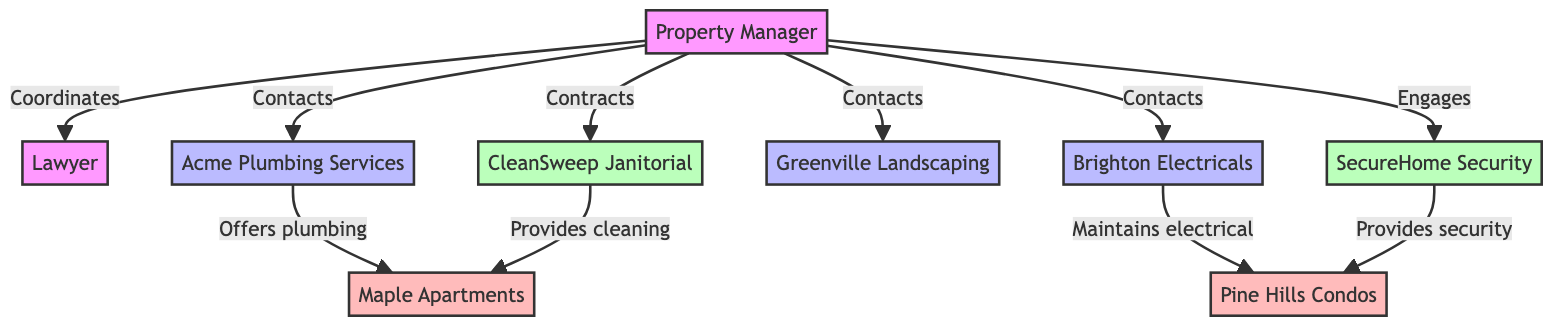What is the role of the Lawyer in the diagram? The diagram indicates that the Lawyer drafts and reviews rental and service agreements, which is highlighted in the relationship between the Property Manager and the Lawyer.
Answer: Drafts and reviews agreements How many contractors are shown in the diagram? By counting the entities listed under Contractors, we identify three contractors: Acme Plumbing Services, Brighton Electricals, and Greenville Landscaping.
Answer: Three Which property does SecureHome Security provide services for? The relationship between SecureHome Security and Pine Hills Condos shows that it provides security services specifically for that property.
Answer: Pine Hills Condos Who contacts Acme Plumbing Services? The Property Manager is connected to Acme Plumbing Services with the relationship labeled "Contacts," indicating that the Property Manager is the one who reaches out to them for plumbing services.
Answer: Property Manager What service does CleanSweep Janitorial provide? The type of relationship linking CleanSweep Janitorial to Maple Apartments indicates that it provides cleaning services, thereby identifying its type of service.
Answer: Cleaning Services Which contractor maintains the electrical systems at Pine Hills Condos? The diagram specifies that Brighton Electricals is linked to Pine Hills Condos with the relationship stating that it maintains electrical systems, thus identifying the contractor responsible for that service.
Answer: Brighton Electricals How many service providers are listed in the diagram? There are two service providers shown in the diagram: CleanSweep Janitorial and SecureHome Security, which can be confirmed by counting the entities listed under Service Providers.
Answer: Two Which property is associated with Acme Plumbing Services? According to the diagram, Acme Plumbing Services is connected to Maple Apartments with a relationship specifying that it offers plumbing solutions for that property.
Answer: Maple Apartments What kind of relationship exists between the Property Manager and the Lawyer? The connection between the Property Manager and the Lawyer is labeled "Coordinates to draft and review agreements," indicating a collaborative relationship for contract management.
Answer: Coordinates to draft and review agreements 